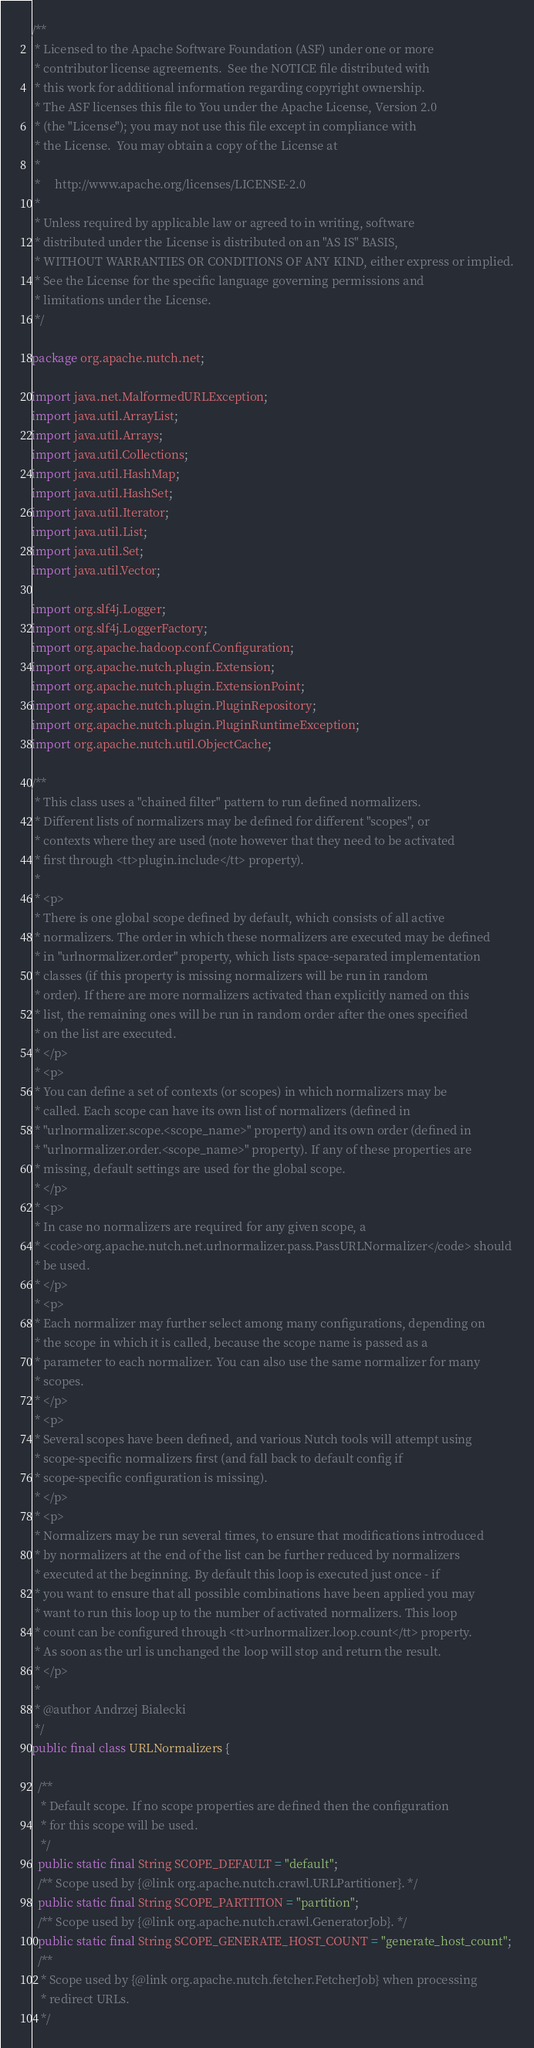<code> <loc_0><loc_0><loc_500><loc_500><_Java_>/**
 * Licensed to the Apache Software Foundation (ASF) under one or more
 * contributor license agreements.  See the NOTICE file distributed with
 * this work for additional information regarding copyright ownership.
 * The ASF licenses this file to You under the Apache License, Version 2.0
 * (the "License"); you may not use this file except in compliance with
 * the License.  You may obtain a copy of the License at
 *
 *     http://www.apache.org/licenses/LICENSE-2.0
 *
 * Unless required by applicable law or agreed to in writing, software
 * distributed under the License is distributed on an "AS IS" BASIS,
 * WITHOUT WARRANTIES OR CONDITIONS OF ANY KIND, either express or implied.
 * See the License for the specific language governing permissions and
 * limitations under the License.
 */

package org.apache.nutch.net;

import java.net.MalformedURLException;
import java.util.ArrayList;
import java.util.Arrays;
import java.util.Collections;
import java.util.HashMap;
import java.util.HashSet;
import java.util.Iterator;
import java.util.List;
import java.util.Set;
import java.util.Vector;

import org.slf4j.Logger;
import org.slf4j.LoggerFactory;
import org.apache.hadoop.conf.Configuration;
import org.apache.nutch.plugin.Extension;
import org.apache.nutch.plugin.ExtensionPoint;
import org.apache.nutch.plugin.PluginRepository;
import org.apache.nutch.plugin.PluginRuntimeException;
import org.apache.nutch.util.ObjectCache;

/**
 * This class uses a "chained filter" pattern to run defined normalizers.
 * Different lists of normalizers may be defined for different "scopes", or
 * contexts where they are used (note however that they need to be activated
 * first through <tt>plugin.include</tt> property).
 * 
 * <p>
 * There is one global scope defined by default, which consists of all active
 * normalizers. The order in which these normalizers are executed may be defined
 * in "urlnormalizer.order" property, which lists space-separated implementation
 * classes (if this property is missing normalizers will be run in random
 * order). If there are more normalizers activated than explicitly named on this
 * list, the remaining ones will be run in random order after the ones specified
 * on the list are executed.
 * </p>
 * <p>
 * You can define a set of contexts (or scopes) in which normalizers may be
 * called. Each scope can have its own list of normalizers (defined in
 * "urlnormalizer.scope.<scope_name>" property) and its own order (defined in
 * "urlnormalizer.order.<scope_name>" property). If any of these properties are
 * missing, default settings are used for the global scope.
 * </p>
 * <p>
 * In case no normalizers are required for any given scope, a
 * <code>org.apache.nutch.net.urlnormalizer.pass.PassURLNormalizer</code> should
 * be used.
 * </p>
 * <p>
 * Each normalizer may further select among many configurations, depending on
 * the scope in which it is called, because the scope name is passed as a
 * parameter to each normalizer. You can also use the same normalizer for many
 * scopes.
 * </p>
 * <p>
 * Several scopes have been defined, and various Nutch tools will attempt using
 * scope-specific normalizers first (and fall back to default config if
 * scope-specific configuration is missing).
 * </p>
 * <p>
 * Normalizers may be run several times, to ensure that modifications introduced
 * by normalizers at the end of the list can be further reduced by normalizers
 * executed at the beginning. By default this loop is executed just once - if
 * you want to ensure that all possible combinations have been applied you may
 * want to run this loop up to the number of activated normalizers. This loop
 * count can be configured through <tt>urlnormalizer.loop.count</tt> property.
 * As soon as the url is unchanged the loop will stop and return the result.
 * </p>
 * 
 * @author Andrzej Bialecki
 */
public final class URLNormalizers {

  /**
   * Default scope. If no scope properties are defined then the configuration
   * for this scope will be used.
   */
  public static final String SCOPE_DEFAULT = "default";
  /** Scope used by {@link org.apache.nutch.crawl.URLPartitioner}. */
  public static final String SCOPE_PARTITION = "partition";
  /** Scope used by {@link org.apache.nutch.crawl.GeneratorJob}. */
  public static final String SCOPE_GENERATE_HOST_COUNT = "generate_host_count";
  /**
   * Scope used by {@link org.apache.nutch.fetcher.FetcherJob} when processing
   * redirect URLs.
   */</code> 